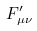Convert formula to latex. <formula><loc_0><loc_0><loc_500><loc_500>F _ { \mu \nu } ^ { \prime }</formula> 